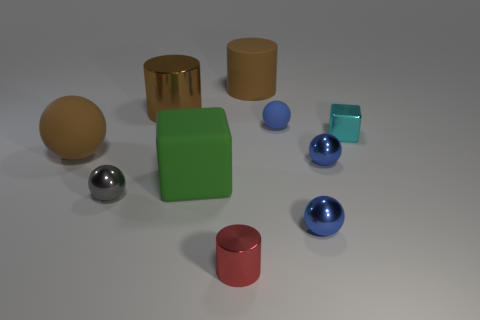There is a small cyan metal object behind the small blue metallic sphere that is behind the small shiny sphere that is in front of the gray ball; what shape is it?
Provide a short and direct response. Cube. There is a cyan metal thing that is the same shape as the green rubber thing; what is its size?
Make the answer very short. Small. What is the size of the object that is on the left side of the tiny red cylinder and behind the cyan block?
Ensure brevity in your answer.  Large. What shape is the large metal object that is the same color as the big matte cylinder?
Your response must be concise. Cylinder. What color is the rubber cylinder?
Your answer should be compact. Brown. How big is the metallic ball that is to the left of the big brown matte cylinder?
Provide a short and direct response. Small. There is a tiny metallic ball on the left side of the brown thing that is right of the red metallic thing; what number of big brown cylinders are in front of it?
Provide a succinct answer. 0. There is a large object that is to the left of the small sphere left of the brown rubber cylinder; what is its color?
Make the answer very short. Brown. Are there any purple cylinders that have the same size as the brown rubber cylinder?
Keep it short and to the point. No. There is a small ball behind the brown thing in front of the metallic cylinder to the left of the large green matte block; what is its material?
Provide a succinct answer. Rubber. 